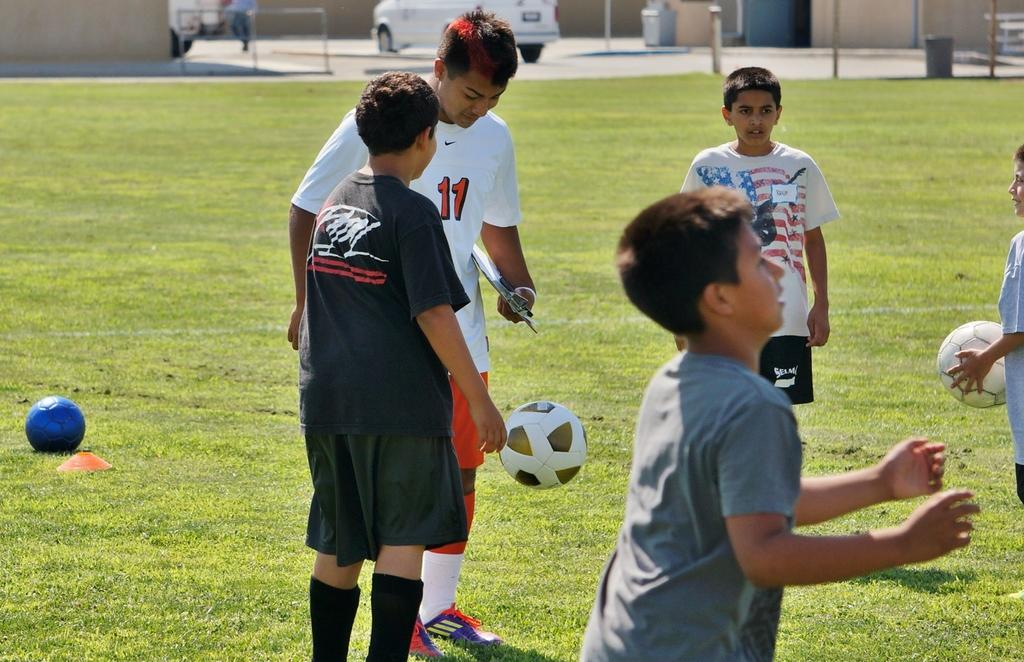How many children are in the image? There are many children in the image. Where are the children located in the image? The children are on the ground. What type of expert advice can be seen in the image? There is no expert advice present in the image; it features many children on the ground. 